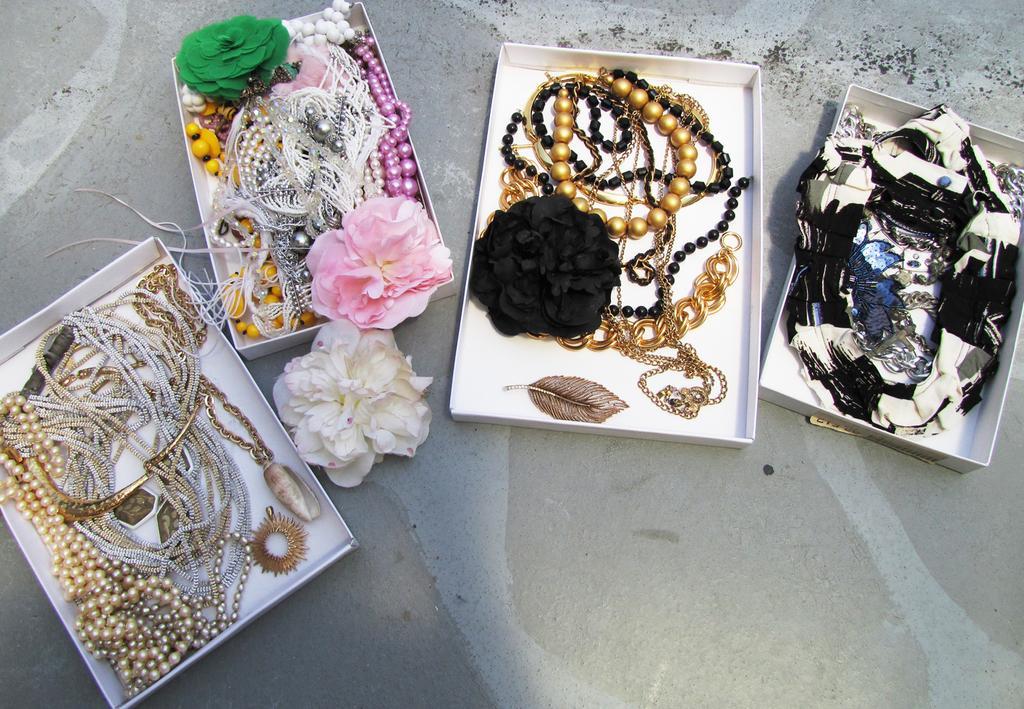Can you describe this image briefly? We can see pearls chains,flowers,feather and some ornaments in boxes and we can see a white flower on the surface. 